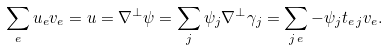<formula> <loc_0><loc_0><loc_500><loc_500>\sum _ { e } u _ { e } v _ { e } = u = \nabla ^ { \perp } \psi = \sum _ { j } \psi _ { j } \nabla ^ { \perp } \gamma _ { j } = \sum _ { j \, e } - \psi _ { j } t _ { e \, j } v _ { e } .</formula> 